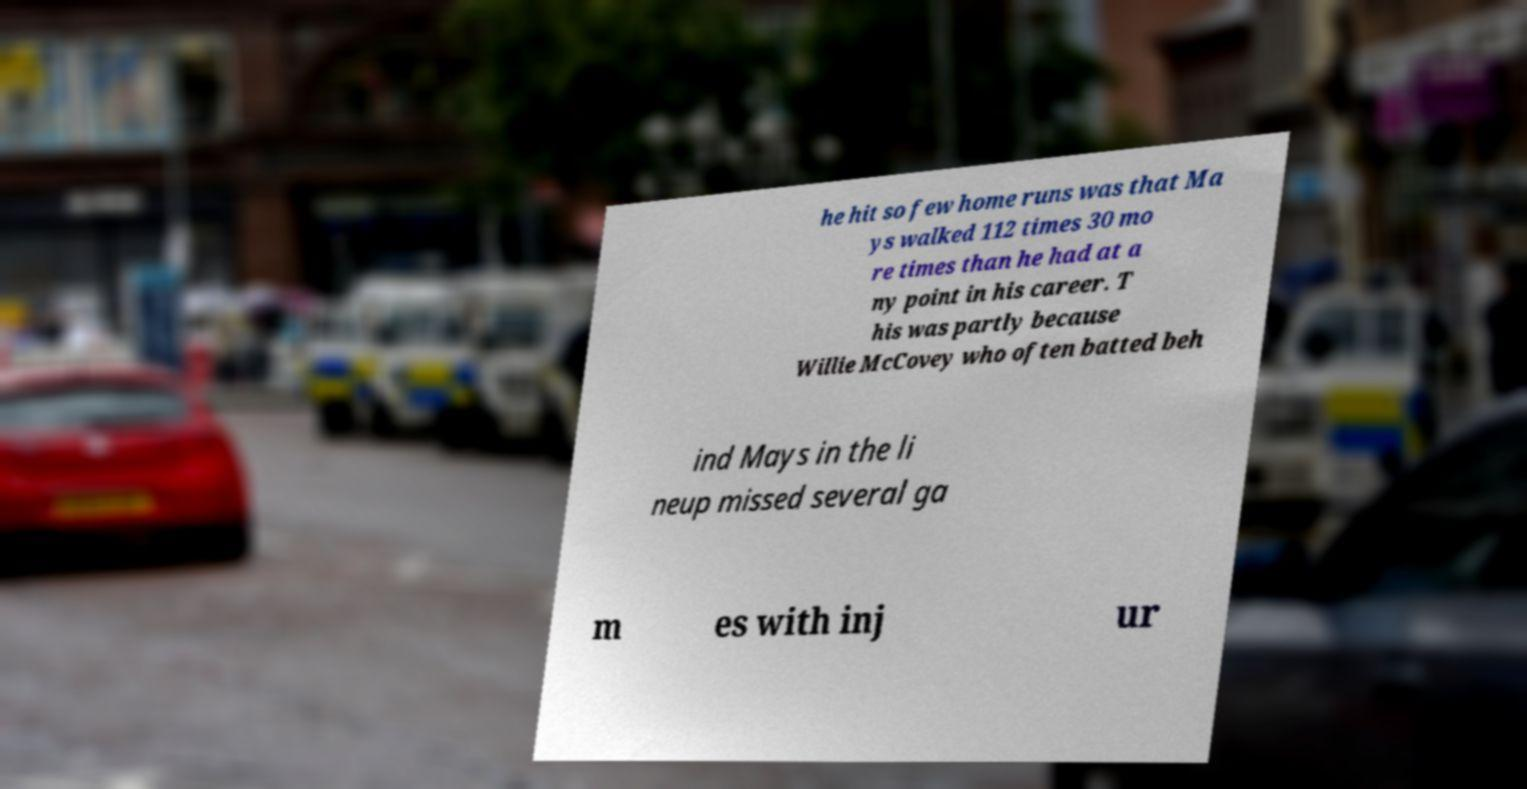Could you extract and type out the text from this image? he hit so few home runs was that Ma ys walked 112 times 30 mo re times than he had at a ny point in his career. T his was partly because Willie McCovey who often batted beh ind Mays in the li neup missed several ga m es with inj ur 